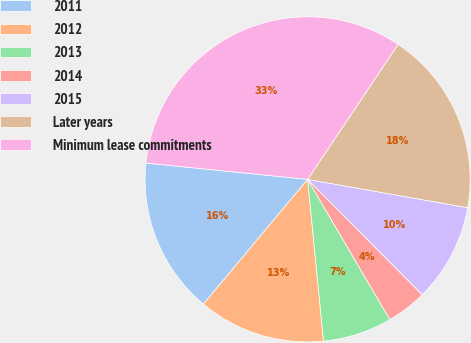<chart> <loc_0><loc_0><loc_500><loc_500><pie_chart><fcel>2011<fcel>2012<fcel>2013<fcel>2014<fcel>2015<fcel>Later years<fcel>Minimum lease commitments<nl><fcel>15.52%<fcel>12.64%<fcel>6.88%<fcel>4.01%<fcel>9.76%<fcel>18.4%<fcel>32.79%<nl></chart> 